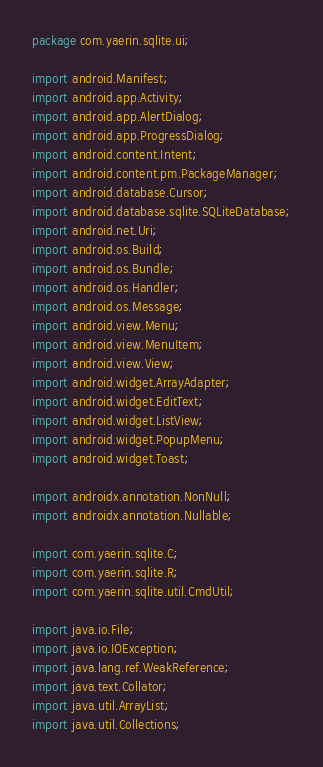Convert code to text. <code><loc_0><loc_0><loc_500><loc_500><_Java_>package com.yaerin.sqlite.ui;

import android.Manifest;
import android.app.Activity;
import android.app.AlertDialog;
import android.app.ProgressDialog;
import android.content.Intent;
import android.content.pm.PackageManager;
import android.database.Cursor;
import android.database.sqlite.SQLiteDatabase;
import android.net.Uri;
import android.os.Build;
import android.os.Bundle;
import android.os.Handler;
import android.os.Message;
import android.view.Menu;
import android.view.MenuItem;
import android.view.View;
import android.widget.ArrayAdapter;
import android.widget.EditText;
import android.widget.ListView;
import android.widget.PopupMenu;
import android.widget.Toast;

import androidx.annotation.NonNull;
import androidx.annotation.Nullable;

import com.yaerin.sqlite.C;
import com.yaerin.sqlite.R;
import com.yaerin.sqlite.util.CmdUtil;

import java.io.File;
import java.io.IOException;
import java.lang.ref.WeakReference;
import java.text.Collator;
import java.util.ArrayList;
import java.util.Collections;</code> 